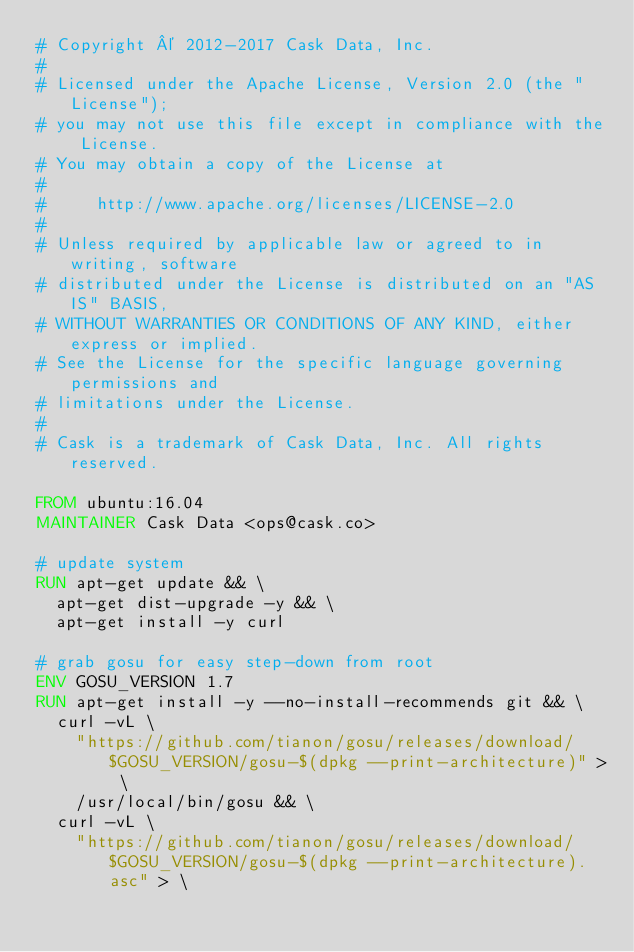<code> <loc_0><loc_0><loc_500><loc_500><_Dockerfile_># Copyright © 2012-2017 Cask Data, Inc.
#
# Licensed under the Apache License, Version 2.0 (the "License");
# you may not use this file except in compliance with the License.
# You may obtain a copy of the License at
#
#     http://www.apache.org/licenses/LICENSE-2.0
#
# Unless required by applicable law or agreed to in writing, software
# distributed under the License is distributed on an "AS IS" BASIS,
# WITHOUT WARRANTIES OR CONDITIONS OF ANY KIND, either express or implied.
# See the License for the specific language governing permissions and
# limitations under the License.
#
# Cask is a trademark of Cask Data, Inc. All rights reserved.

FROM ubuntu:16.04
MAINTAINER Cask Data <ops@cask.co>

# update system
RUN apt-get update && \
  apt-get dist-upgrade -y && \
  apt-get install -y curl

# grab gosu for easy step-down from root
ENV GOSU_VERSION 1.7
RUN apt-get install -y --no-install-recommends git && \
  curl -vL \
    "https://github.com/tianon/gosu/releases/download/$GOSU_VERSION/gosu-$(dpkg --print-architecture)" > \
    /usr/local/bin/gosu && \
  curl -vL \
    "https://github.com/tianon/gosu/releases/download/$GOSU_VERSION/gosu-$(dpkg --print-architecture).asc" > \</code> 